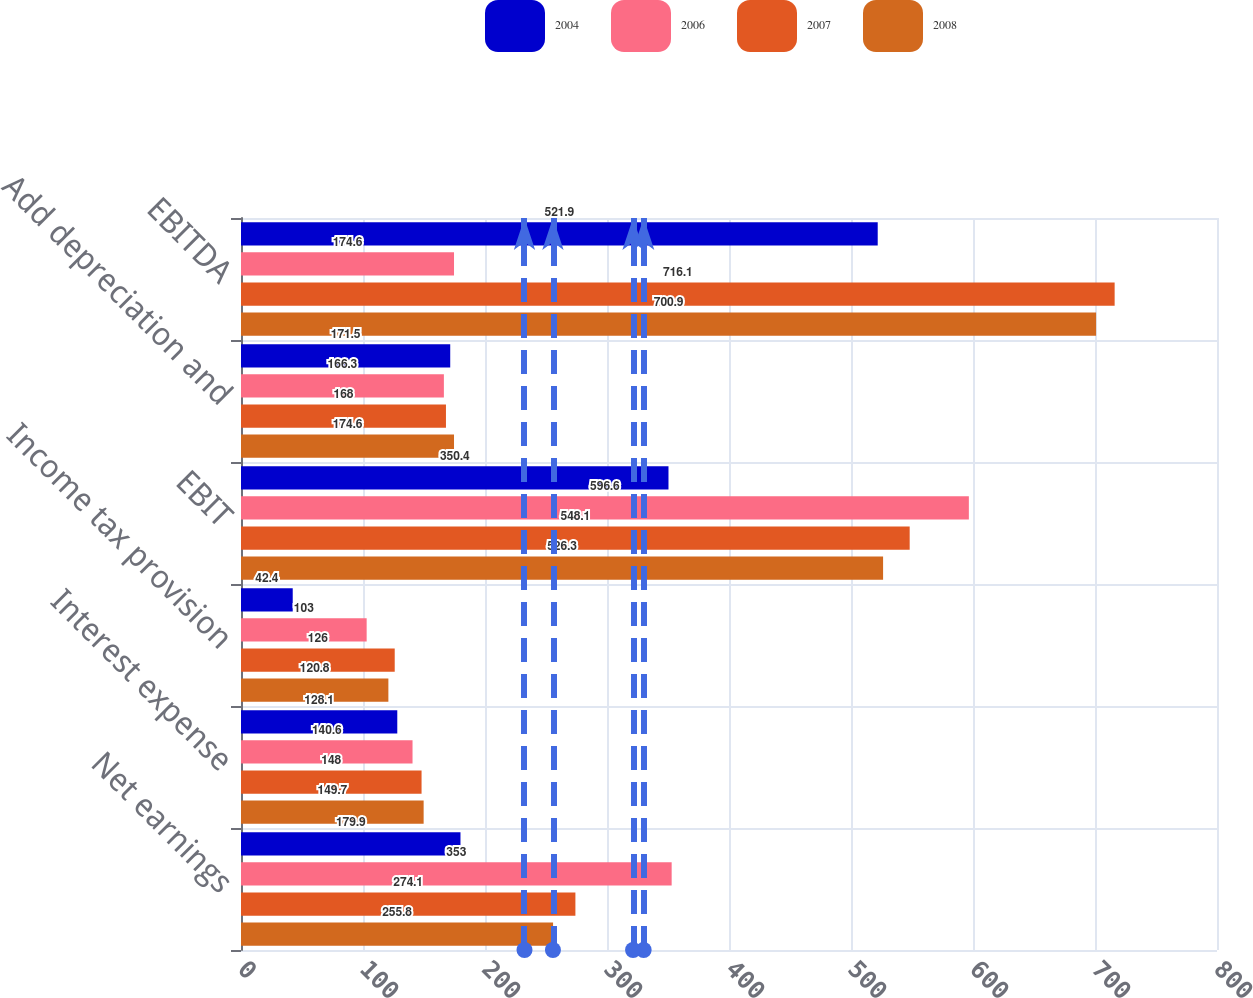Convert chart. <chart><loc_0><loc_0><loc_500><loc_500><stacked_bar_chart><ecel><fcel>Net earnings<fcel>Interest expense<fcel>Income tax provision<fcel>EBIT<fcel>Add depreciation and<fcel>EBITDA<nl><fcel>2004<fcel>179.9<fcel>128.1<fcel>42.4<fcel>350.4<fcel>171.5<fcel>521.9<nl><fcel>2006<fcel>353<fcel>140.6<fcel>103<fcel>596.6<fcel>166.3<fcel>174.6<nl><fcel>2007<fcel>274.1<fcel>148<fcel>126<fcel>548.1<fcel>168<fcel>716.1<nl><fcel>2008<fcel>255.8<fcel>149.7<fcel>120.8<fcel>526.3<fcel>174.6<fcel>700.9<nl></chart> 